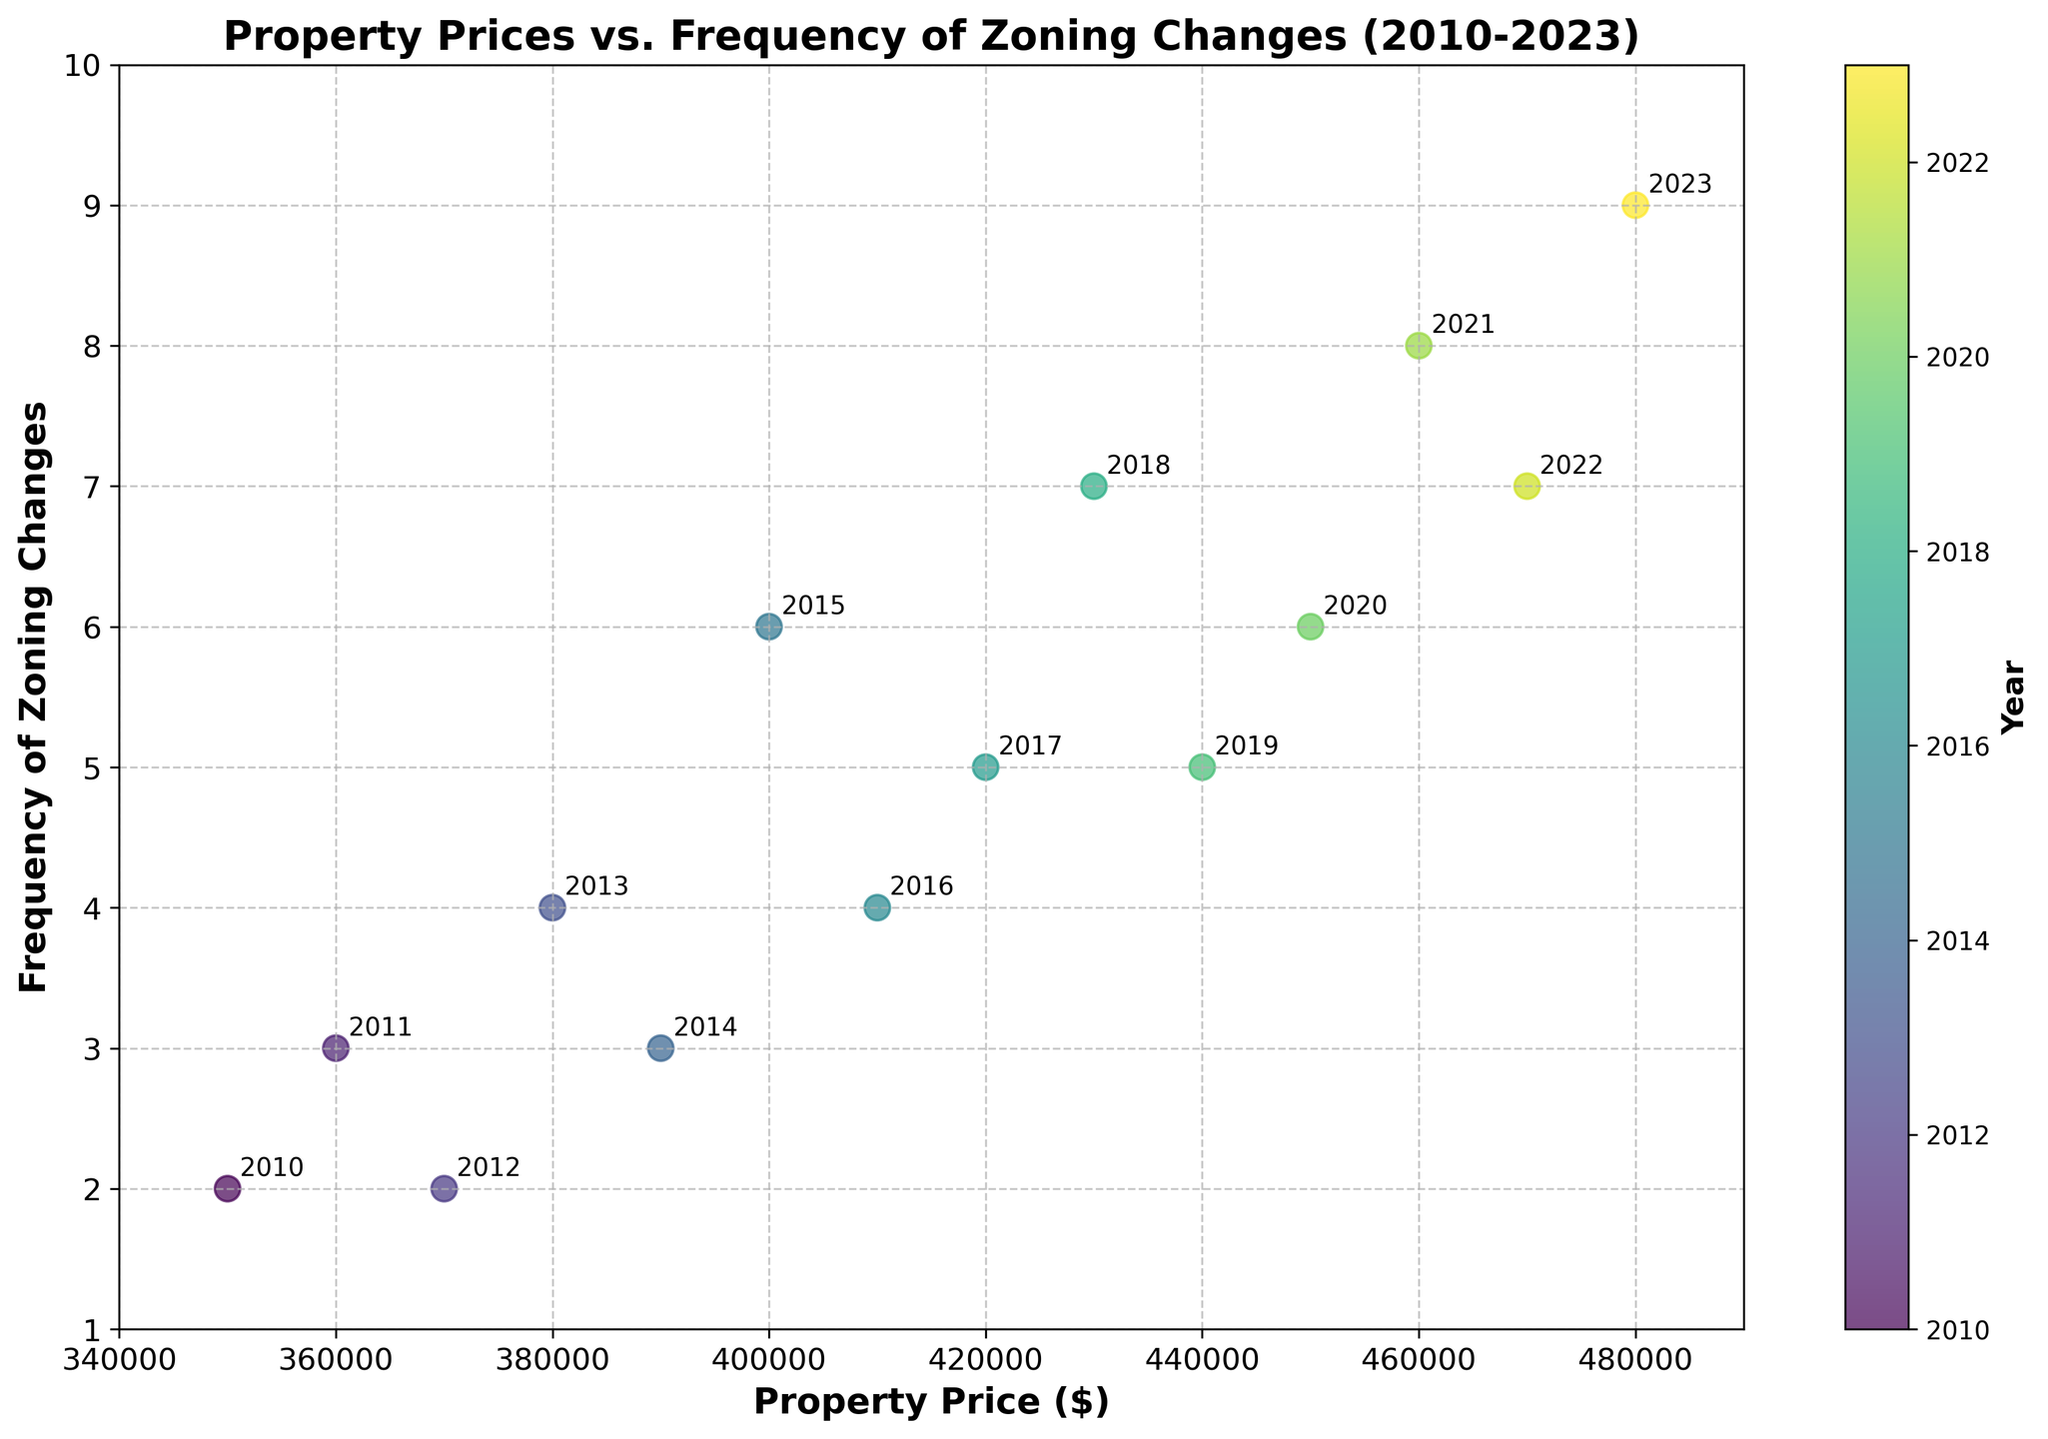What is the title of the scatter plot? The title of the scatter plot is found at the top center of the figure. It provides a concise description of the data being visualized.
Answer: Property Prices vs. Frequency of Zoning Changes (2010-2023) What does the color gradient in the scatter plot represent? The color gradient is indicated by the color bar on the right side of the plot. It shows the relationship between the color of the data points and a specific variable.
Answer: Year How many data points are there in the scatter plot? Each data point represents a unique (Property Price, Frequency of Zoning Changes) pair. By counting the points, the total number is determined.
Answer: 14 Which year is represented by the data point (450000, 6)? The data points have numerical labels represented as years. This specific point's year label can be identified directly from the plot.
Answer: 2020 What is the range of property prices shown in the scatter plot? The range of property prices can be determined by finding the minimum and maximum values on the x-axis. The axis spans from 340000 to 490000.
Answer: 350000 to 480000 Which year had the highest frequency of zoning changes? Find the data point with the highest y-value and read its year label using the color gradient or annotation.
Answer: 2023 Did the frequency of zoning changes generally increase or decrease over time? By observing the overall trend from earlier years to later years on the plot, one can determine the general direction of the y-values.
Answer: Increase Is there a positive or negative correlation between property prices and the frequency of zoning changes? By observing the scatter plot pattern, determine if higher property prices tend to align with higher frequencies. Here, as prices increase, the frequency generally increases too.
Answer: Positive 